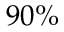<formula> <loc_0><loc_0><loc_500><loc_500>9 0 \%</formula> 